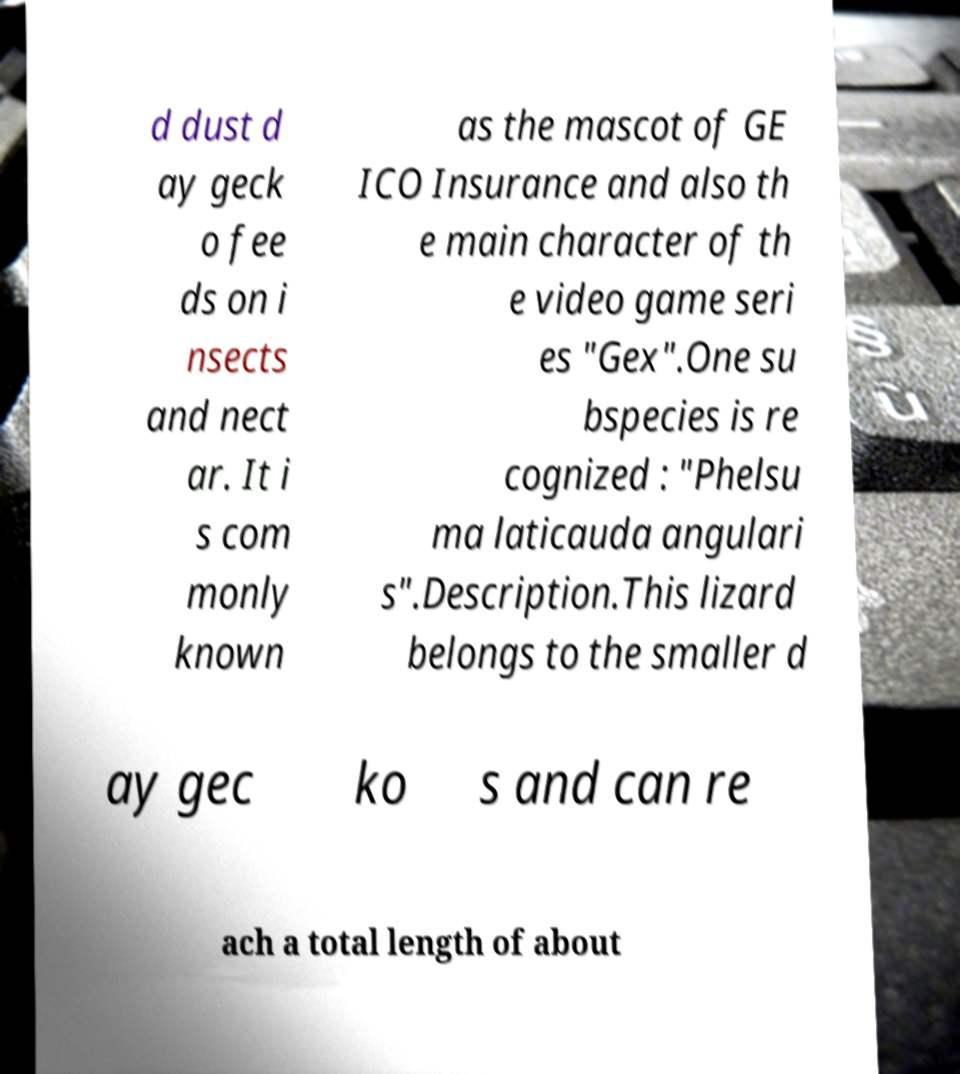What messages or text are displayed in this image? I need them in a readable, typed format. d dust d ay geck o fee ds on i nsects and nect ar. It i s com monly known as the mascot of GE ICO Insurance and also th e main character of th e video game seri es "Gex".One su bspecies is re cognized : "Phelsu ma laticauda angulari s".Description.This lizard belongs to the smaller d ay gec ko s and can re ach a total length of about 